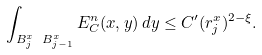Convert formula to latex. <formula><loc_0><loc_0><loc_500><loc_500>\int _ { B ^ { x } _ { j } \ B ^ { x } _ { j - 1 } } E ^ { n } _ { C } ( x , y ) \, d y \leq C ^ { \prime } ( r ^ { x } _ { j } ) ^ { 2 - \xi } .</formula> 